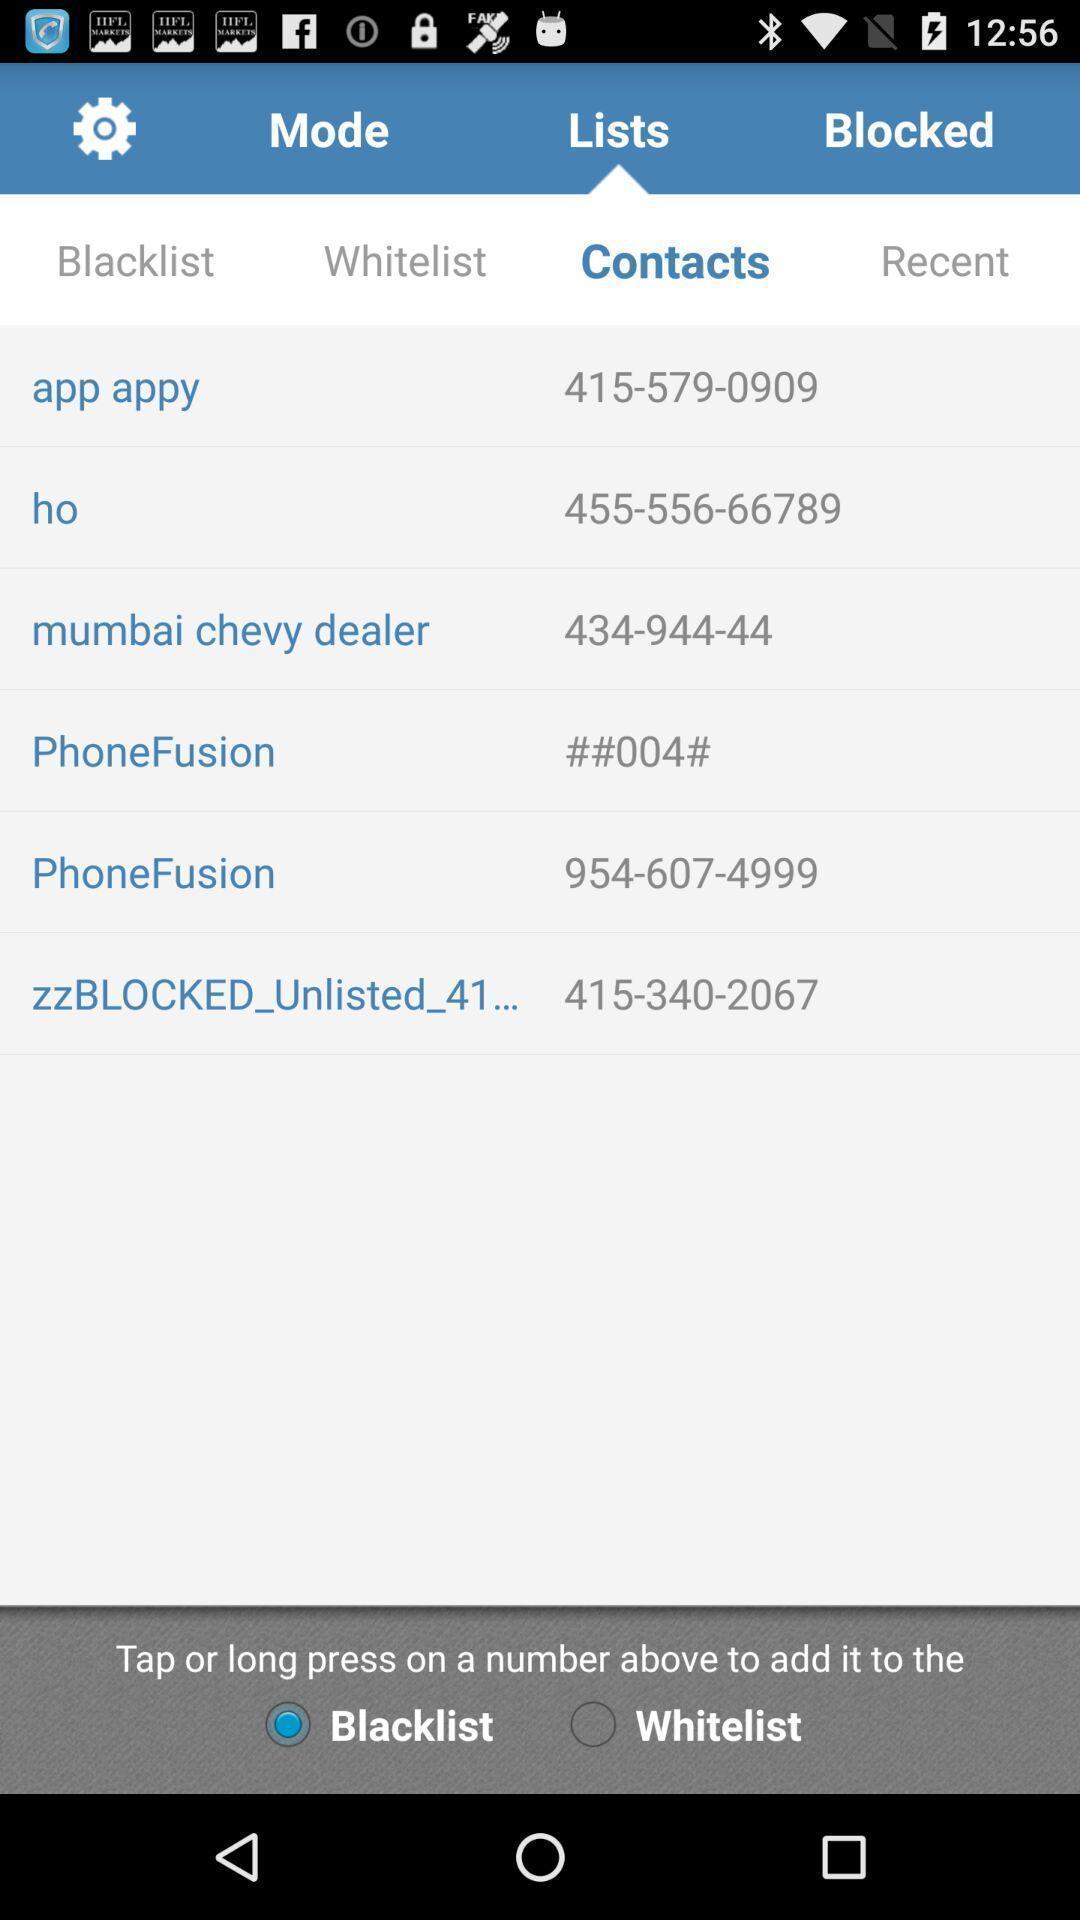Describe the key features of this screenshot. Screen shows contacts details. 